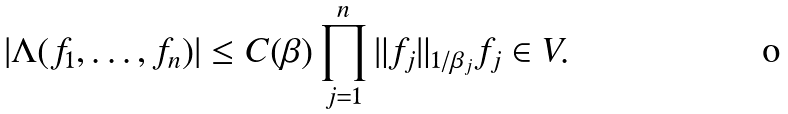<formula> <loc_0><loc_0><loc_500><loc_500>| \Lambda ( f _ { 1 } , \dots , f _ { n } ) | \leq C ( \beta ) \prod _ { j = 1 } ^ { n } \| f _ { j } \| _ { 1 / { \beta _ { j } } } f _ { j } \in V .</formula> 